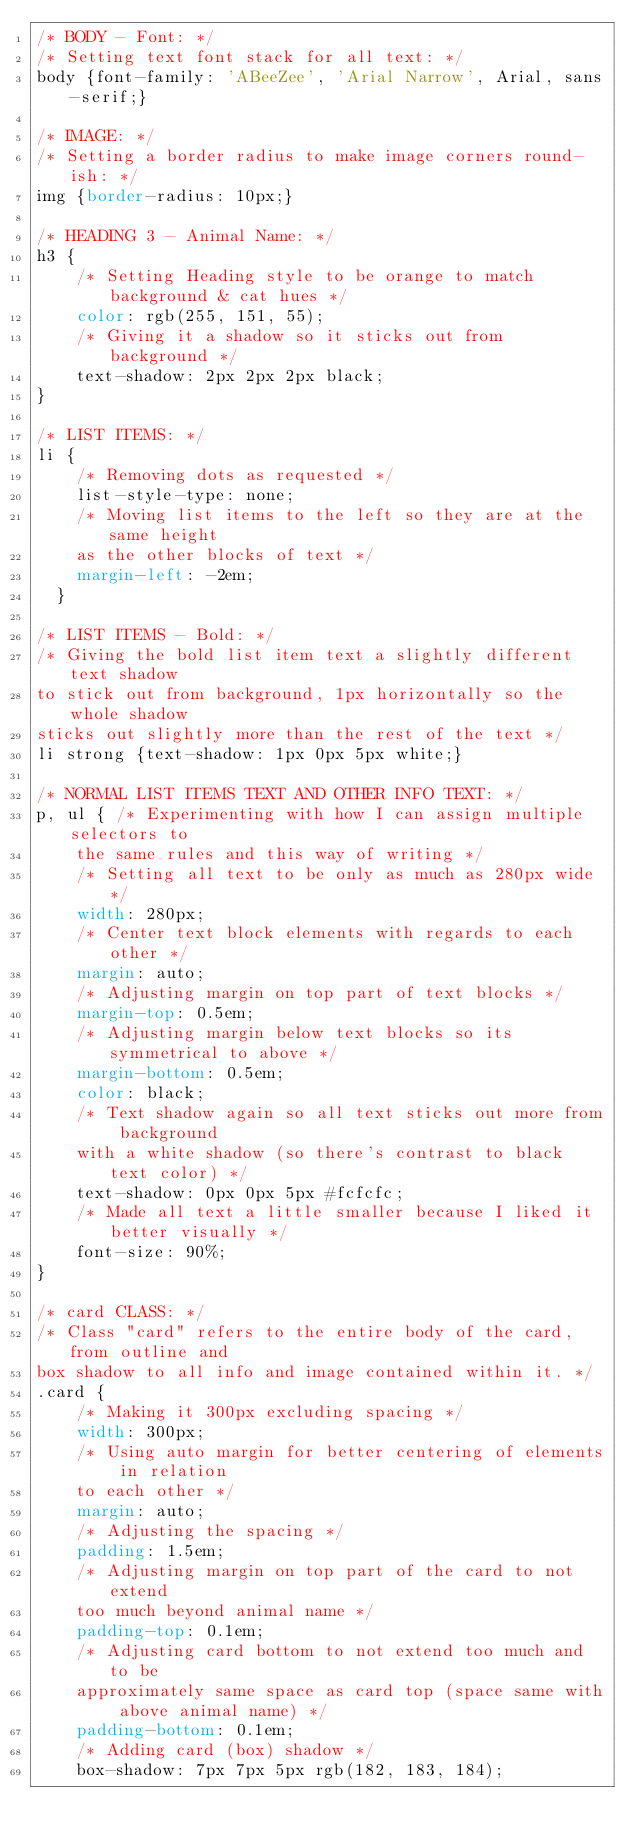<code> <loc_0><loc_0><loc_500><loc_500><_CSS_>/* BODY - Font: */
/* Setting text font stack for all text: */
body {font-family: 'ABeeZee', 'Arial Narrow', Arial, sans-serif;} 

/* IMAGE: */
/* Setting a border radius to make image corners round-ish: */
img {border-radius: 10px;} 

/* HEADING 3 - Animal Name: */
h3 {
    /* Setting Heading style to be orange to match background & cat hues */
    color: rgb(255, 151, 55); 
    /* Giving it a shadow so it sticks out from background */ 
    text-shadow: 2px 2px 2px black; 
}

/* LIST ITEMS: */
li {
    /* Removing dots as requested */
    list-style-type: none; 
    /* Moving list items to the left so they are at the same height 
    as the other blocks of text */
    margin-left: -2em; 
  }

/* LIST ITEMS - Bold: */
/* Giving the bold list item text a slightly different text shadow 
to stick out from background, 1px horizontally so the whole shadow 
sticks out slightly more than the rest of the text */
li strong {text-shadow: 1px 0px 5px white;} 

/* NORMAL LIST ITEMS TEXT AND OTHER INFO TEXT: */
p, ul { /* Experimenting with how I can assign multiple selectors to 
    the same rules and this way of writing */
    /* Setting all text to be only as much as 280px wide */
    width: 280px; 
    /* Center text block elements with regards to each other */
    margin: auto; 
    /* Adjusting margin on top part of text blocks */
    margin-top: 0.5em; 
    /* Adjusting margin below text blocks so its symmetrical to above */
    margin-bottom: 0.5em; 
    color: black; 
    /* Text shadow again so all text sticks out more from background 
    with a white shadow (so there's contrast to black text color) */
    text-shadow: 0px 0px 5px #fcfcfc; 
    /* Made all text a little smaller because I liked it better visually */
    font-size: 90%; 
}

/* card CLASS: */
/* Class "card" refers to the entire body of the card, from outline and 
box shadow to all info and image contained within it. */
.card {
    /* Making it 300px excluding spacing */
    width: 300px; 
    /* Using auto margin for better centering of elements in relation 
    to each other */
    margin: auto; 
    /* Adjusting the spacing */
    padding: 1.5em; 
    /* Adjusting margin on top part of the card to not extend 
    too much beyond animal name */
    padding-top: 0.1em; 
    /* Adjusting card bottom to not extend too much and to be 
    approximately same space as card top (space same with above animal name) */
    padding-bottom: 0.1em; 
    /* Adding card (box) shadow */
    box-shadow: 7px 7px 5px rgb(182, 183, 184); </code> 